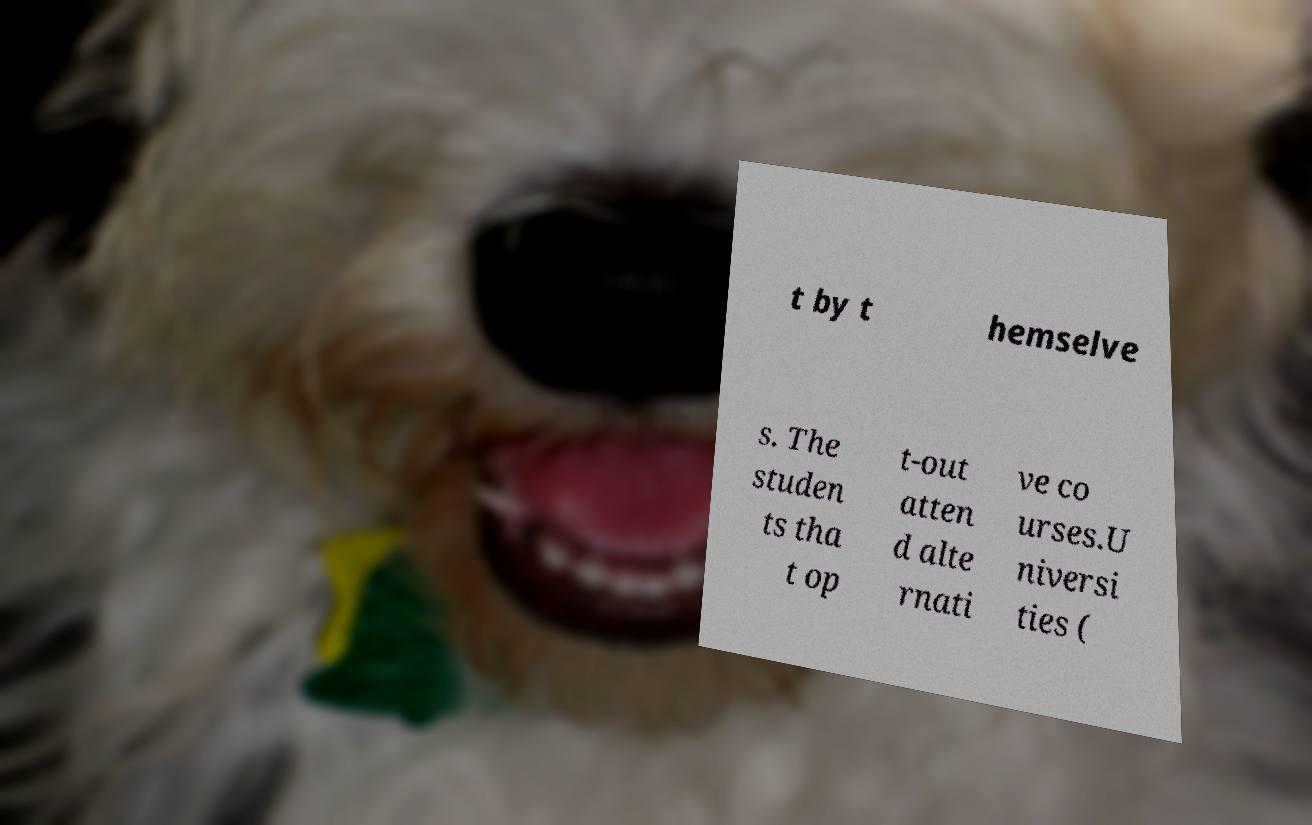Please identify and transcribe the text found in this image. t by t hemselve s. The studen ts tha t op t-out atten d alte rnati ve co urses.U niversi ties ( 